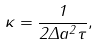<formula> <loc_0><loc_0><loc_500><loc_500>\kappa = \frac { 1 } { 2 \Delta a ^ { 2 } \tau } ,</formula> 